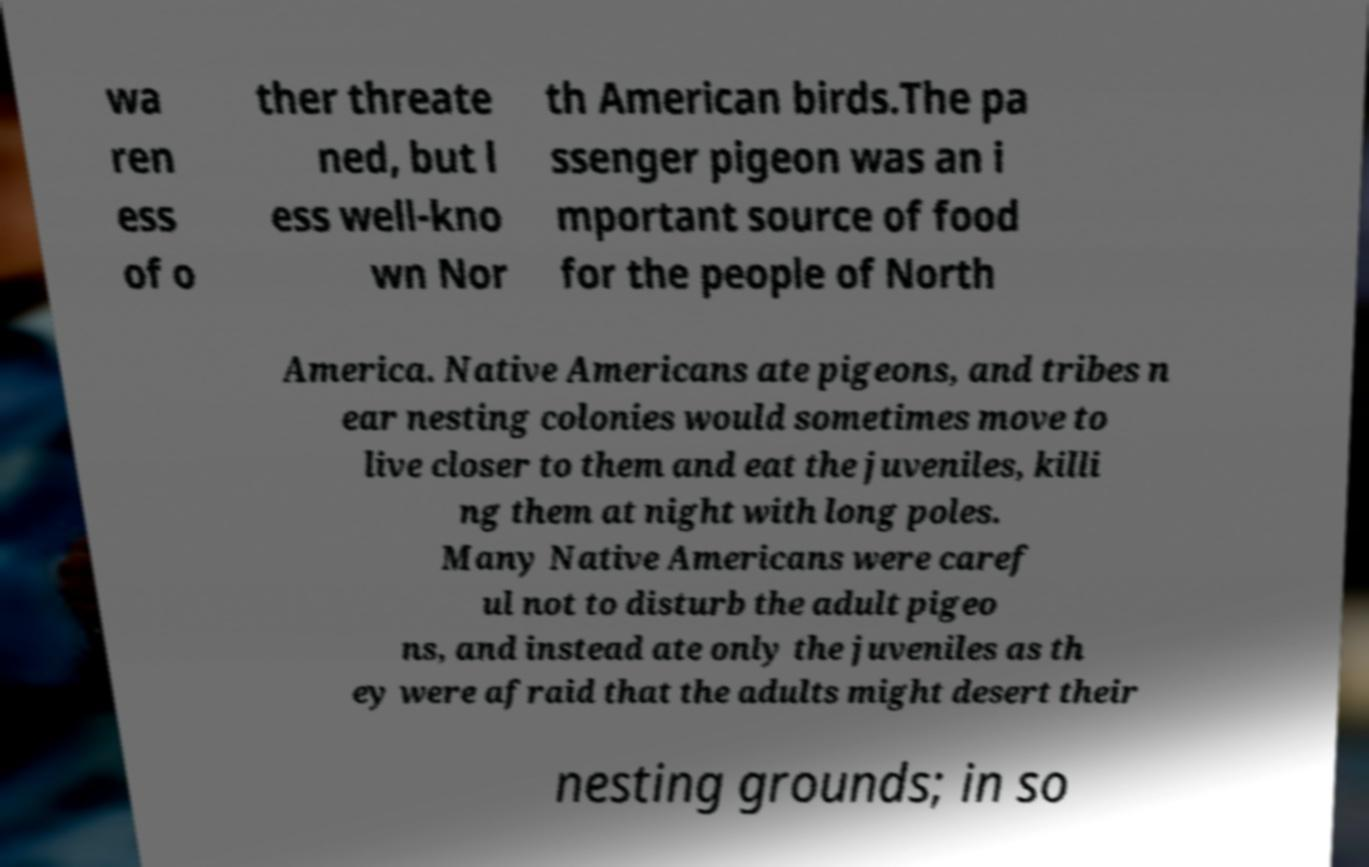Can you read and provide the text displayed in the image?This photo seems to have some interesting text. Can you extract and type it out for me? wa ren ess of o ther threate ned, but l ess well-kno wn Nor th American birds.The pa ssenger pigeon was an i mportant source of food for the people of North America. Native Americans ate pigeons, and tribes n ear nesting colonies would sometimes move to live closer to them and eat the juveniles, killi ng them at night with long poles. Many Native Americans were caref ul not to disturb the adult pigeo ns, and instead ate only the juveniles as th ey were afraid that the adults might desert their nesting grounds; in so 